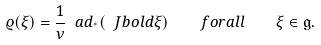<formula> <loc_0><loc_0><loc_500><loc_500>\varrho ( \xi ) = \frac { 1 } { \nu } \ a d _ { ^ { * } } ( \ J b o l d { \xi } ) \quad f o r a l l \quad \xi \in \mathfrak g .</formula> 